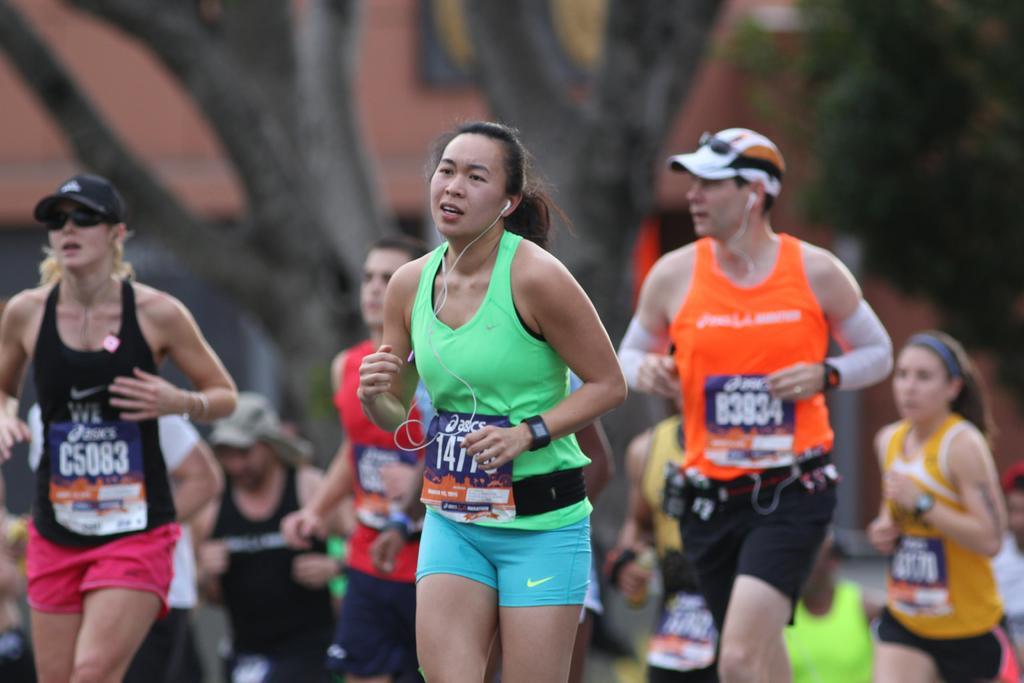How would you summarize this image in a sentence or two? In this picture we can see some people running, in the background there are trees and a building, these two persons wore caps. 